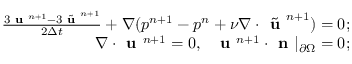Convert formula to latex. <formula><loc_0><loc_0><loc_500><loc_500>\begin{array} { r l r } & { \frac { 3 u ^ { n + 1 } - 3 \tilde { u } ^ { n + 1 } } { 2 \Delta t } + \nabla ( p ^ { n + 1 } - p ^ { n } + \nu \nabla \cdot \tilde { u } ^ { n + 1 } ) = 0 ; } \\ & { \nabla \cdot u ^ { n + 1 } = 0 , \ \ u ^ { n + 1 } \cdot n | _ { \partial \Omega } = 0 ; } \end{array}</formula> 